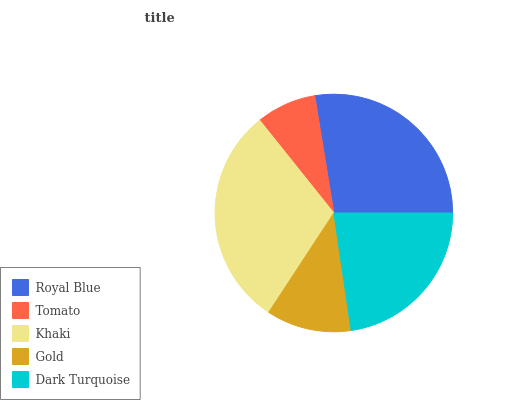Is Tomato the minimum?
Answer yes or no. Yes. Is Khaki the maximum?
Answer yes or no. Yes. Is Khaki the minimum?
Answer yes or no. No. Is Tomato the maximum?
Answer yes or no. No. Is Khaki greater than Tomato?
Answer yes or no. Yes. Is Tomato less than Khaki?
Answer yes or no. Yes. Is Tomato greater than Khaki?
Answer yes or no. No. Is Khaki less than Tomato?
Answer yes or no. No. Is Dark Turquoise the high median?
Answer yes or no. Yes. Is Dark Turquoise the low median?
Answer yes or no. Yes. Is Tomato the high median?
Answer yes or no. No. Is Gold the low median?
Answer yes or no. No. 